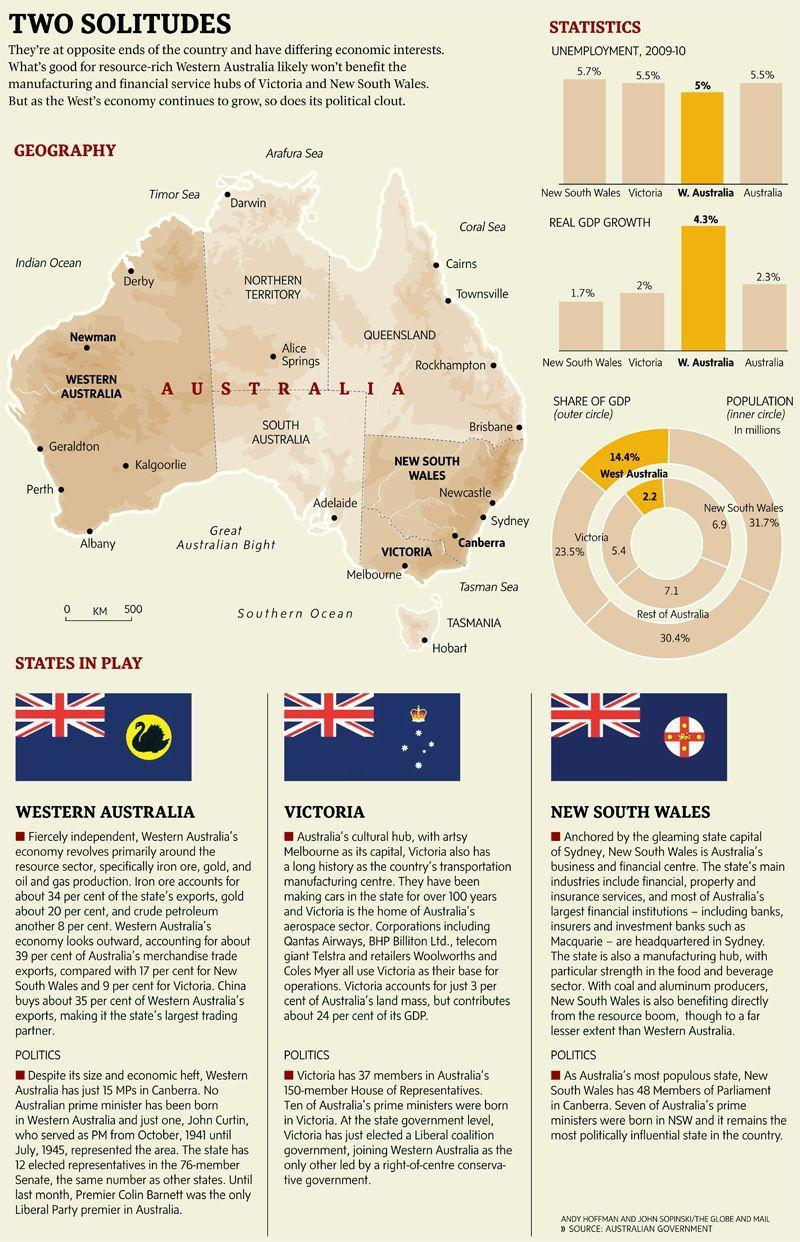Which state is Australia's cultural hub?
Answer the question with a short phrase. Victoria Which state has the second highest real GDP growth? Australia What is the total percentage of unemployment, 2009-10. in New South Wales and Victoria? 11.2% Which is the most politically influential state in the country? new south wales 